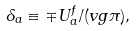Convert formula to latex. <formula><loc_0><loc_0><loc_500><loc_500>\delta _ { a } \equiv \mp U _ { a } ^ { f } / ( v g \pi ) ,</formula> 